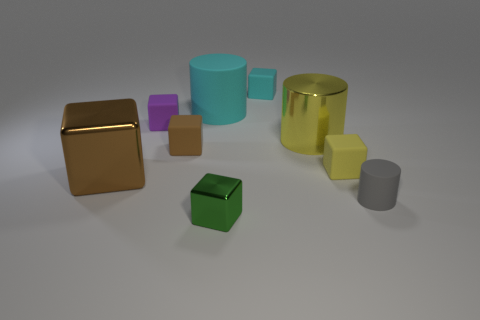Subtract all yellow matte blocks. How many blocks are left? 5 Subtract all green cubes. How many cubes are left? 5 Subtract 5 cubes. How many cubes are left? 1 Subtract all green cylinders. How many brown blocks are left? 2 Add 1 large cyan cylinders. How many objects exist? 10 Subtract all cylinders. How many objects are left? 6 Subtract all gray cylinders. Subtract all gray cubes. How many cylinders are left? 2 Subtract all tiny purple rubber balls. Subtract all small green objects. How many objects are left? 8 Add 9 tiny purple objects. How many tiny purple objects are left? 10 Add 2 cyan metal cubes. How many cyan metal cubes exist? 2 